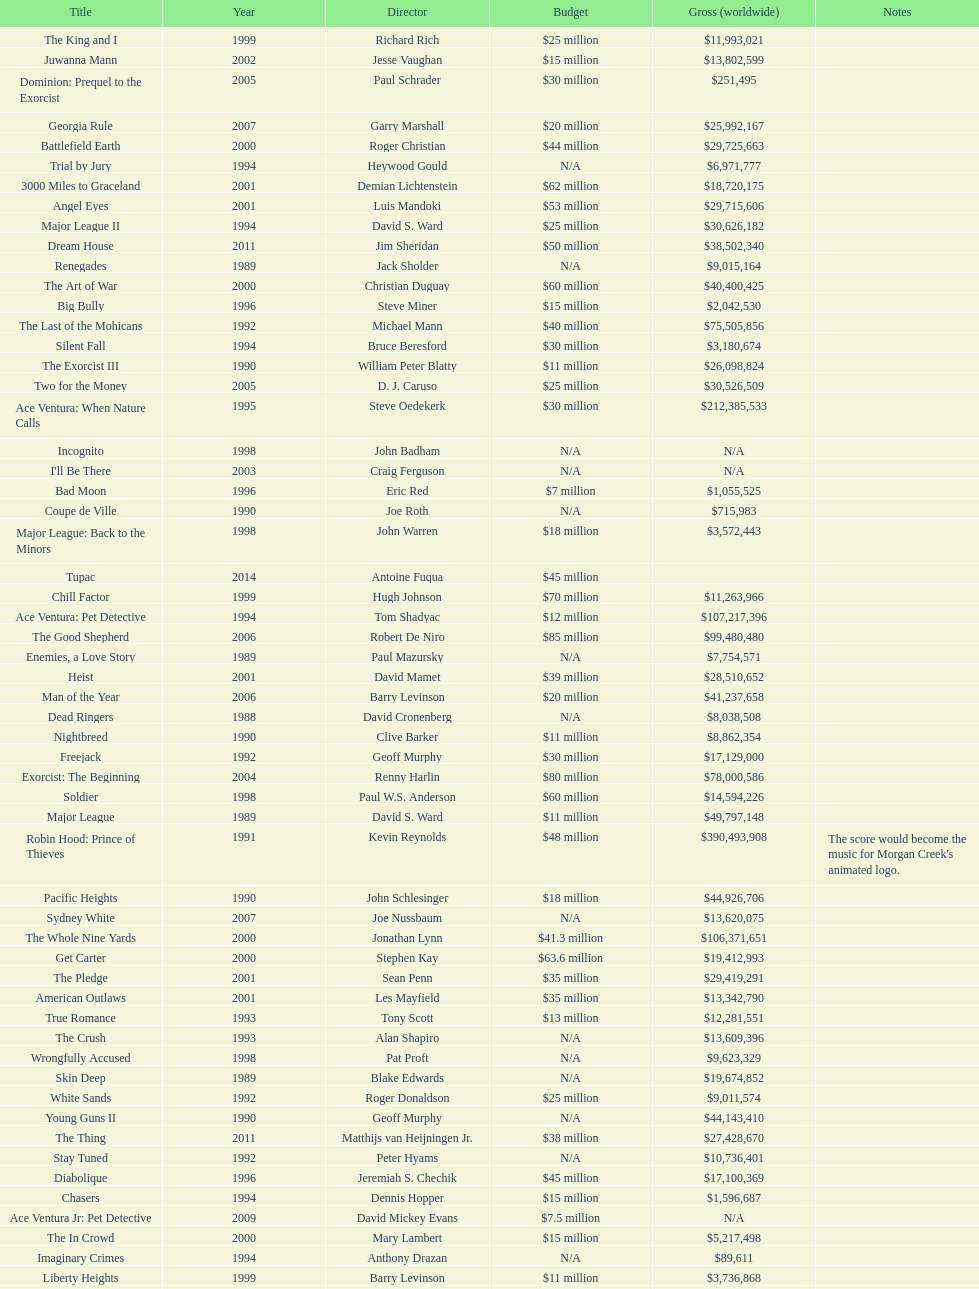Which morgan creek film grossed the most money prior to 1994? Robin Hood: Prince of Thieves. Write the full table. {'header': ['Title', 'Year', 'Director', 'Budget', 'Gross (worldwide)', 'Notes'], 'rows': [['The King and I', '1999', 'Richard Rich', '$25 million', '$11,993,021', ''], ['Juwanna Mann', '2002', 'Jesse Vaughan', '$15 million', '$13,802,599', ''], ['Dominion: Prequel to the Exorcist', '2005', 'Paul Schrader', '$30 million', '$251,495', ''], ['Georgia Rule', '2007', 'Garry Marshall', '$20 million', '$25,992,167', ''], ['Battlefield Earth', '2000', 'Roger Christian', '$44 million', '$29,725,663', ''], ['Trial by Jury', '1994', 'Heywood Gould', 'N/A', '$6,971,777', ''], ['3000 Miles to Graceland', '2001', 'Demian Lichtenstein', '$62 million', '$18,720,175', ''], ['Angel Eyes', '2001', 'Luis Mandoki', '$53 million', '$29,715,606', ''], ['Major League II', '1994', 'David S. Ward', '$25 million', '$30,626,182', ''], ['Dream House', '2011', 'Jim Sheridan', '$50 million', '$38,502,340', ''], ['Renegades', '1989', 'Jack Sholder', 'N/A', '$9,015,164', ''], ['The Art of War', '2000', 'Christian Duguay', '$60 million', '$40,400,425', ''], ['Big Bully', '1996', 'Steve Miner', '$15 million', '$2,042,530', ''], ['The Last of the Mohicans', '1992', 'Michael Mann', '$40 million', '$75,505,856', ''], ['Silent Fall', '1994', 'Bruce Beresford', '$30 million', '$3,180,674', ''], ['The Exorcist III', '1990', 'William Peter Blatty', '$11 million', '$26,098,824', ''], ['Two for the Money', '2005', 'D. J. Caruso', '$25 million', '$30,526,509', ''], ['Ace Ventura: When Nature Calls', '1995', 'Steve Oedekerk', '$30 million', '$212,385,533', ''], ['Incognito', '1998', 'John Badham', 'N/A', 'N/A', ''], ["I'll Be There", '2003', 'Craig Ferguson', 'N/A', 'N/A', ''], ['Bad Moon', '1996', 'Eric Red', '$7 million', '$1,055,525', ''], ['Coupe de Ville', '1990', 'Joe Roth', 'N/A', '$715,983', ''], ['Major League: Back to the Minors', '1998', 'John Warren', '$18 million', '$3,572,443', ''], ['Tupac', '2014', 'Antoine Fuqua', '$45 million', '', ''], ['Chill Factor', '1999', 'Hugh Johnson', '$70 million', '$11,263,966', ''], ['Ace Ventura: Pet Detective', '1994', 'Tom Shadyac', '$12 million', '$107,217,396', ''], ['The Good Shepherd', '2006', 'Robert De Niro', '$85 million', '$99,480,480', ''], ['Enemies, a Love Story', '1989', 'Paul Mazursky', 'N/A', '$7,754,571', ''], ['Heist', '2001', 'David Mamet', '$39 million', '$28,510,652', ''], ['Man of the Year', '2006', 'Barry Levinson', '$20 million', '$41,237,658', ''], ['Dead Ringers', '1988', 'David Cronenberg', 'N/A', '$8,038,508', ''], ['Nightbreed', '1990', 'Clive Barker', '$11 million', '$8,862,354', ''], ['Freejack', '1992', 'Geoff Murphy', '$30 million', '$17,129,000', ''], ['Exorcist: The Beginning', '2004', 'Renny Harlin', '$80 million', '$78,000,586', ''], ['Soldier', '1998', 'Paul W.S. Anderson', '$60 million', '$14,594,226', ''], ['Major League', '1989', 'David S. Ward', '$11 million', '$49,797,148', ''], ['Robin Hood: Prince of Thieves', '1991', 'Kevin Reynolds', '$48 million', '$390,493,908', "The score would become the music for Morgan Creek's animated logo."], ['Pacific Heights', '1990', 'John Schlesinger', '$18 million', '$44,926,706', ''], ['Sydney White', '2007', 'Joe Nussbaum', 'N/A', '$13,620,075', ''], ['The Whole Nine Yards', '2000', 'Jonathan Lynn', '$41.3 million', '$106,371,651', ''], ['Get Carter', '2000', 'Stephen Kay', '$63.6 million', '$19,412,993', ''], ['The Pledge', '2001', 'Sean Penn', '$35 million', '$29,419,291', ''], ['American Outlaws', '2001', 'Les Mayfield', '$35 million', '$13,342,790', ''], ['True Romance', '1993', 'Tony Scott', '$13 million', '$12,281,551', ''], ['The Crush', '1993', 'Alan Shapiro', 'N/A', '$13,609,396', ''], ['Wrongfully Accused', '1998', 'Pat Proft', 'N/A', '$9,623,329', ''], ['Skin Deep', '1989', 'Blake Edwards', 'N/A', '$19,674,852', ''], ['White Sands', '1992', 'Roger Donaldson', '$25 million', '$9,011,574', ''], ['Young Guns II', '1990', 'Geoff Murphy', 'N/A', '$44,143,410', ''], ['The Thing', '2011', 'Matthijs van Heijningen Jr.', '$38 million', '$27,428,670', ''], ['Stay Tuned', '1992', 'Peter Hyams', 'N/A', '$10,736,401', ''], ['Diabolique', '1996', 'Jeremiah S. Chechik', '$45 million', '$17,100,369', ''], ['Chasers', '1994', 'Dennis Hopper', '$15 million', '$1,596,687', ''], ['Ace Ventura Jr: Pet Detective', '2009', 'David Mickey Evans', '$7.5 million', 'N/A', ''], ['The In Crowd', '2000', 'Mary Lambert', '$15 million', '$5,217,498', ''], ['Imaginary Crimes', '1994', 'Anthony Drazan', 'N/A', '$89,611', ''], ['Liberty Heights', '1999', 'Barry Levinson', '$11 million', '$3,736,868', ''], ['Two If by Sea', '1996', 'Bill Bennett', 'N/A', '$10,658,278', ''], ['Wild America', '1997', 'William Dear', 'N/A', '$7,324,662', ''], ['Young Guns', '1988', 'Christopher Cain', '$11 million', '$45,661,556', '']]} 